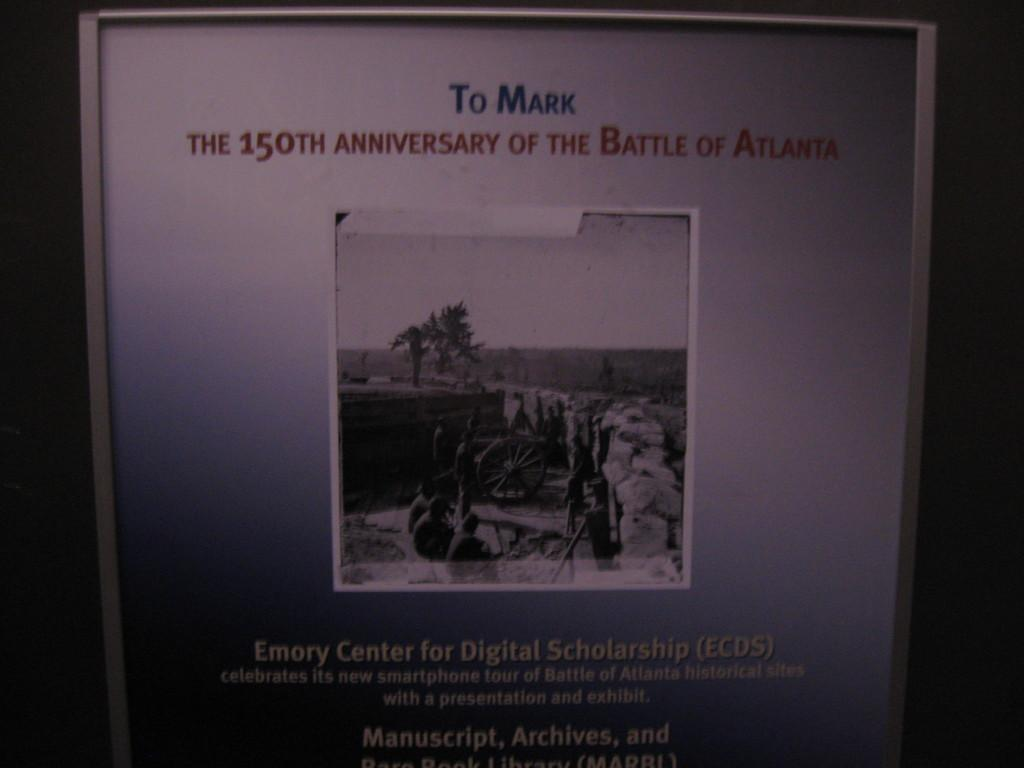What is the main object in the image? There is a notice paper in the image. What information is present on the notice paper? The notice paper contains text. Who is mentioned on the notice paper? There is a person mentioned on the notice paper. What type of images can be seen on the notice paper? There are images of trees on the notice paper. What type of polish is being applied to the street in the image? There is no mention of polish or a street in the image; it features a notice paper with text and images of trees. 